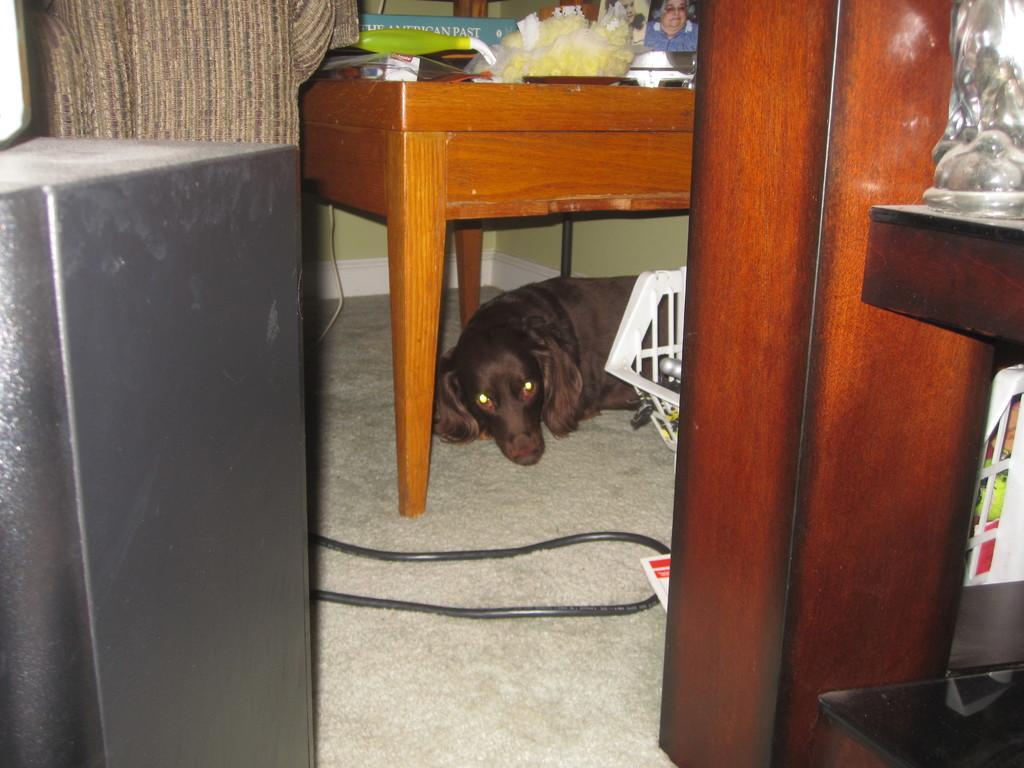Can you describe this image briefly? In this image we can see a dog sleeping under a wooden table. 